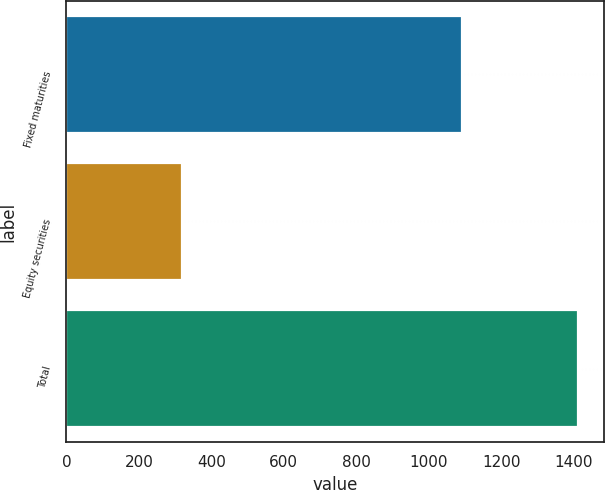Convert chart to OTSL. <chart><loc_0><loc_0><loc_500><loc_500><bar_chart><fcel>Fixed maturities<fcel>Equity securities<fcel>Total<nl><fcel>1093<fcel>320<fcel>1413<nl></chart> 